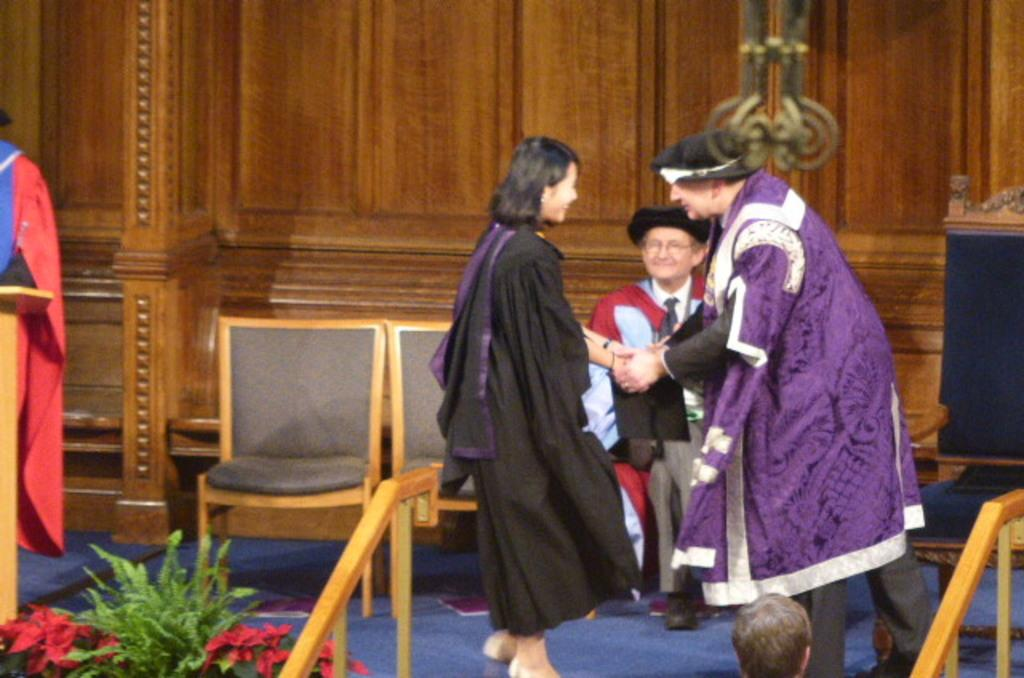What is the primary activity of the people in the image? The people in the image are standing, which suggests they might be waiting or observing something. Can you describe the man's position in the image? One man is sitting on a chair in the image. Are there any other chairs visible in the image? Yes, there are additional chairs visible in the image. What type of tools is the carpenter using in the image? There is no carpenter present in the image, nor are there any tools visible. How much blood can be seen on the people in the image? There is no blood visible on the people in the image. 